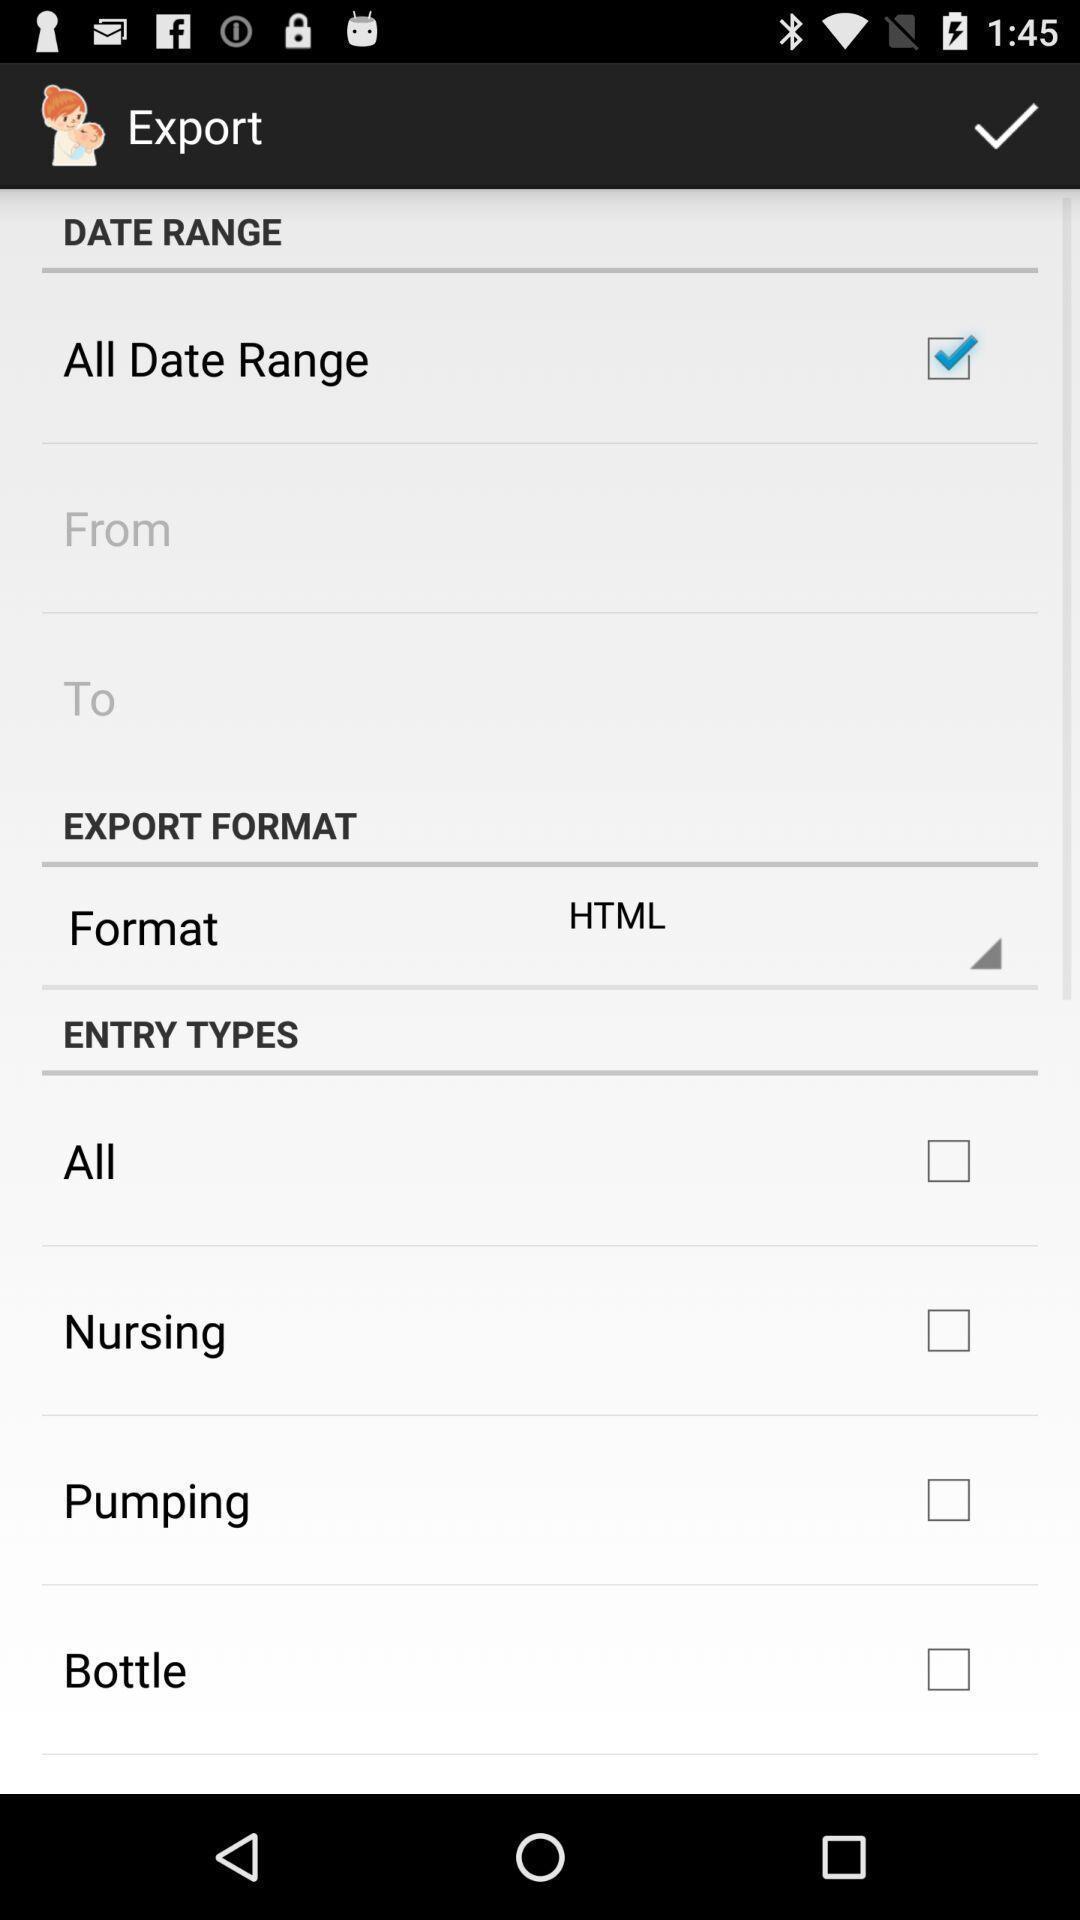What is the overall content of this screenshot? Page shows the different export setting options. 